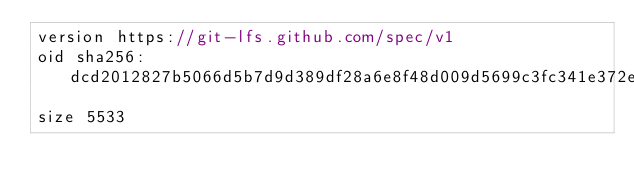<code> <loc_0><loc_0><loc_500><loc_500><_C_>version https://git-lfs.github.com/spec/v1
oid sha256:dcd2012827b5066d5b7d9d389df28a6e8f48d009d5699c3fc341e372eebe81b3
size 5533
</code> 